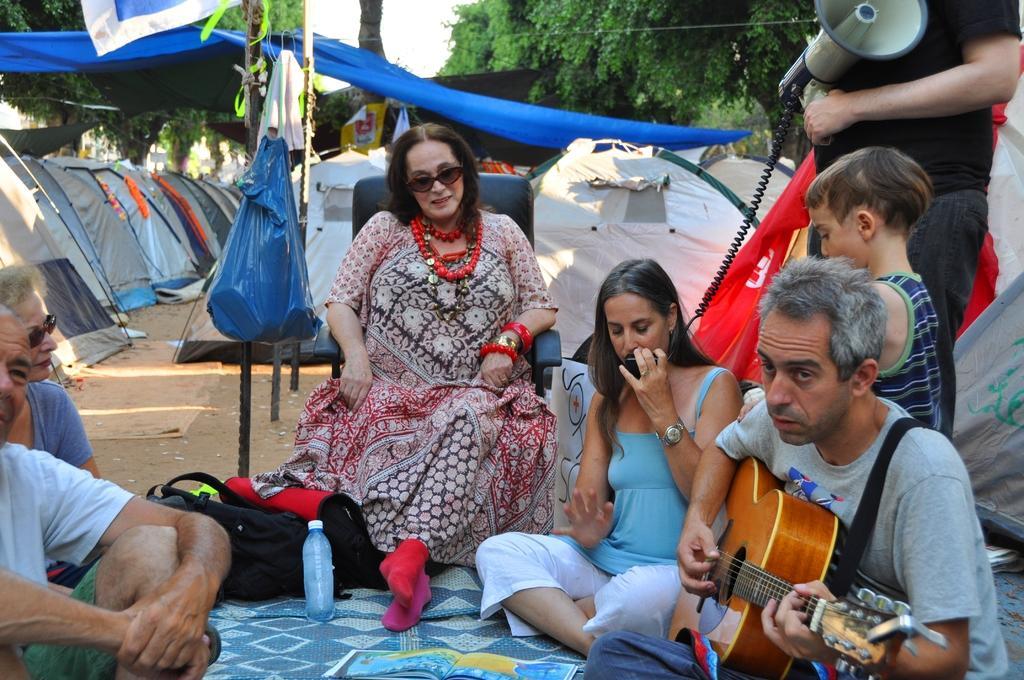In one or two sentences, can you explain what this image depicts? In this image there is a woman sitting in the chair, some group of people sitting another group of people sitting in the mat there is a bottle , book in the mat and a bag ,and at the back ground there is a tree , speaker , bag , some tents. 